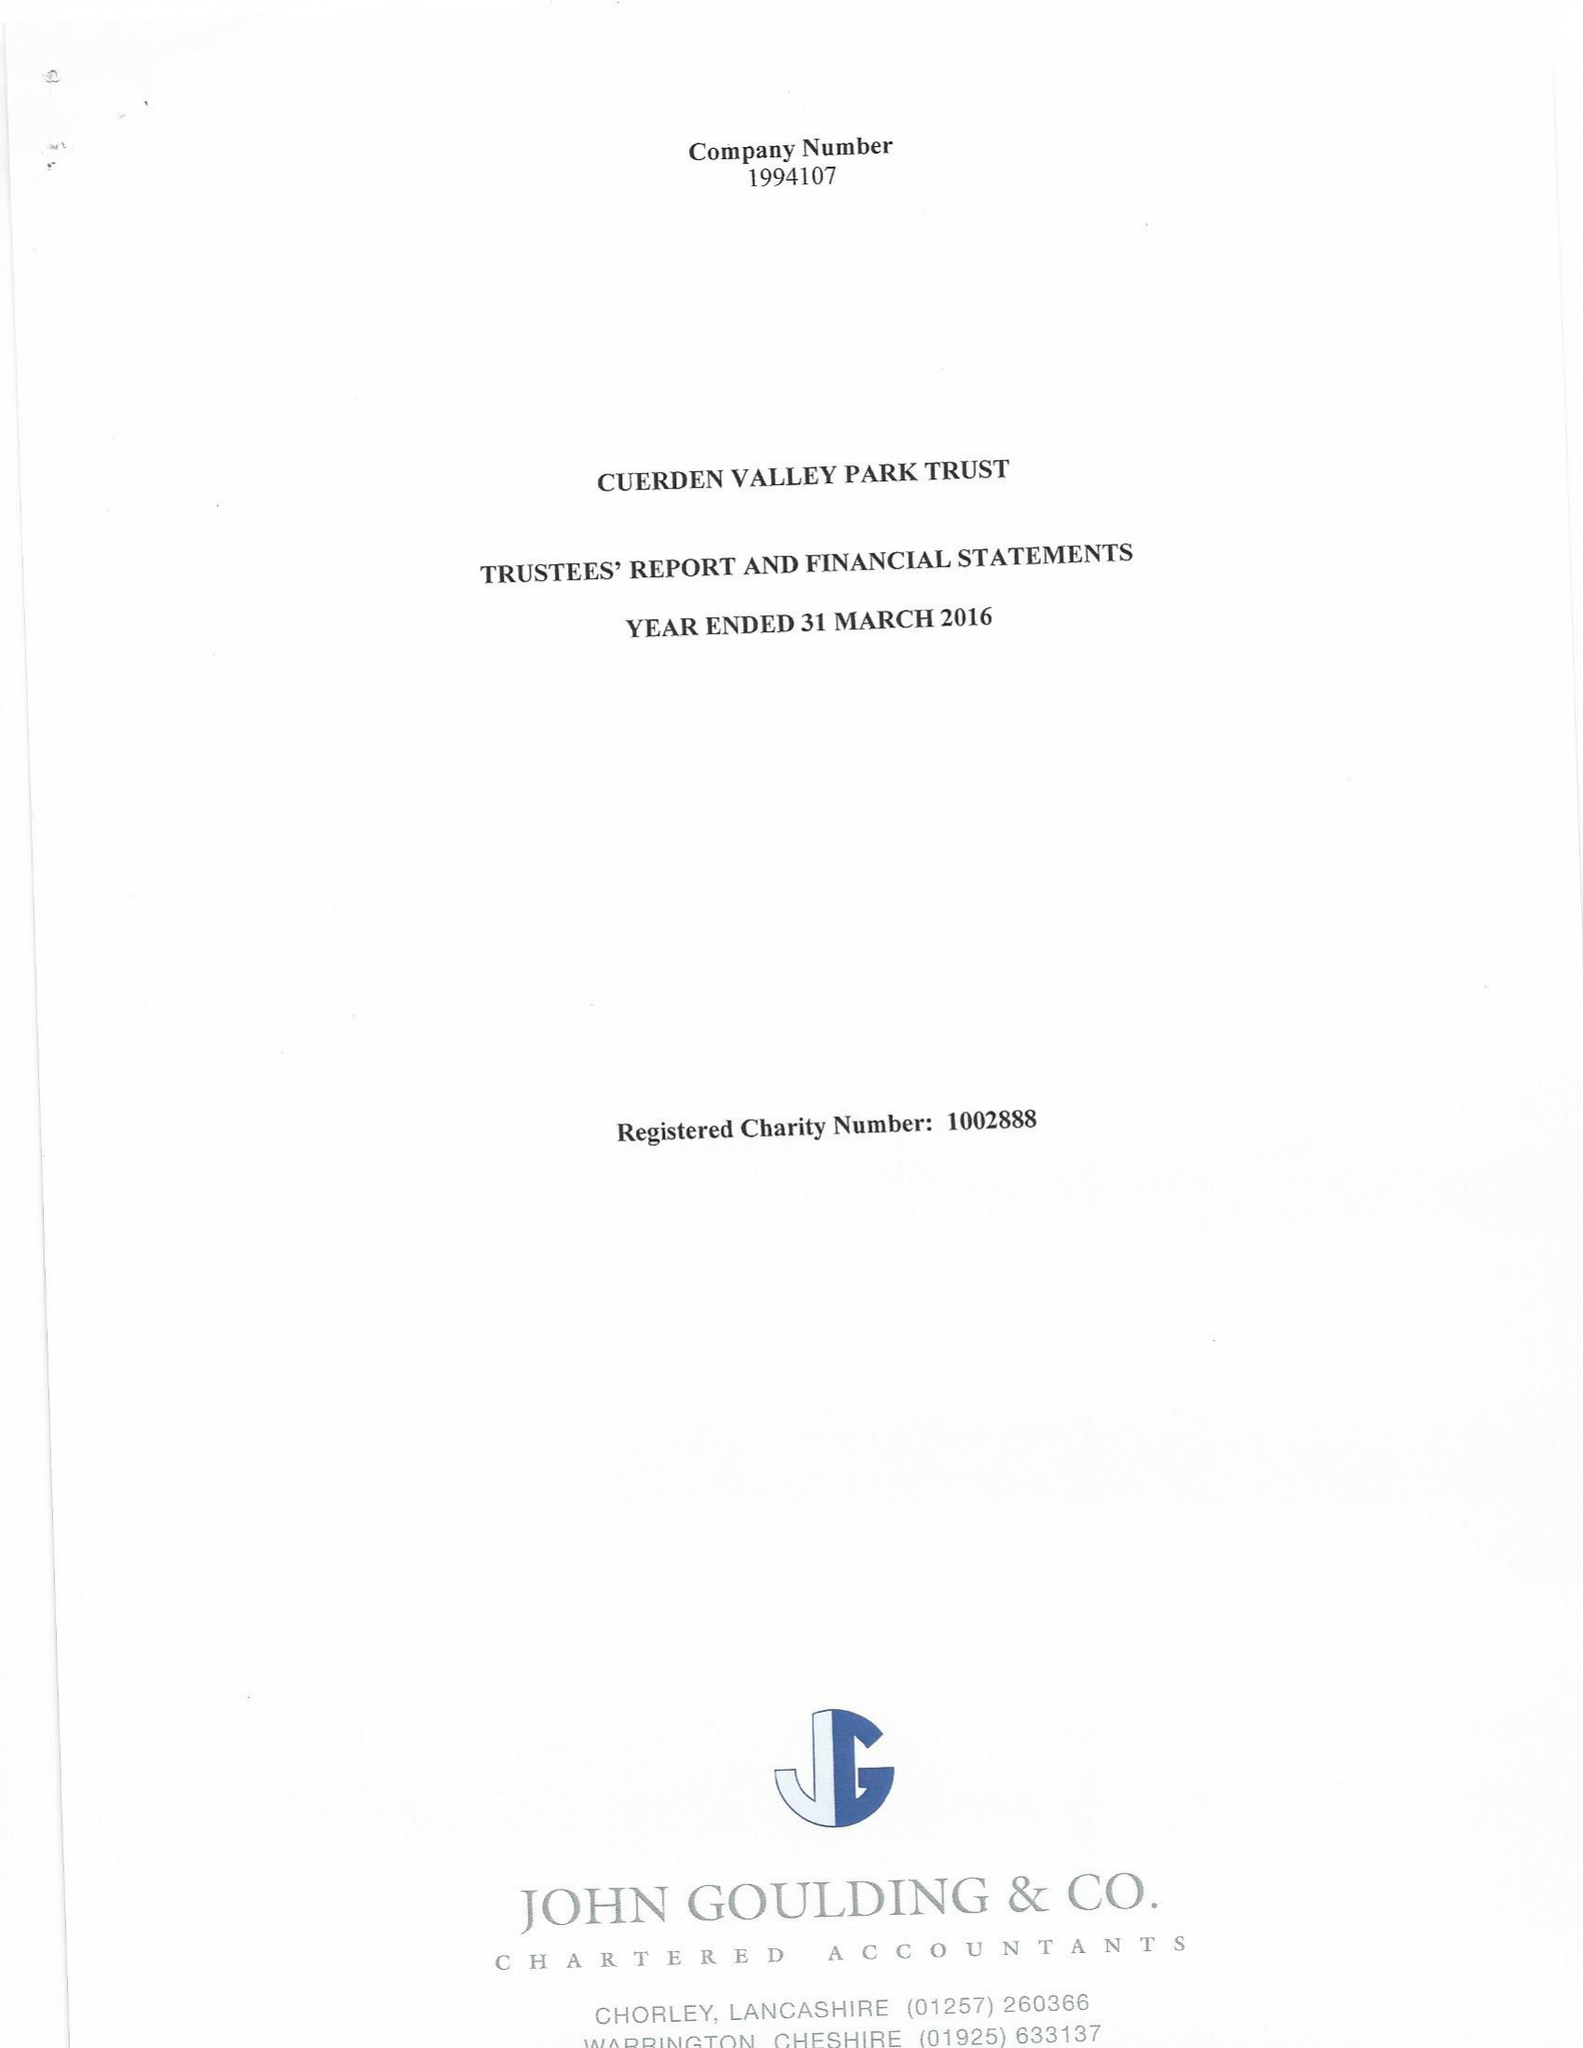What is the value for the address__street_line?
Answer the question using a single word or phrase. BERKELEY DRIVE 